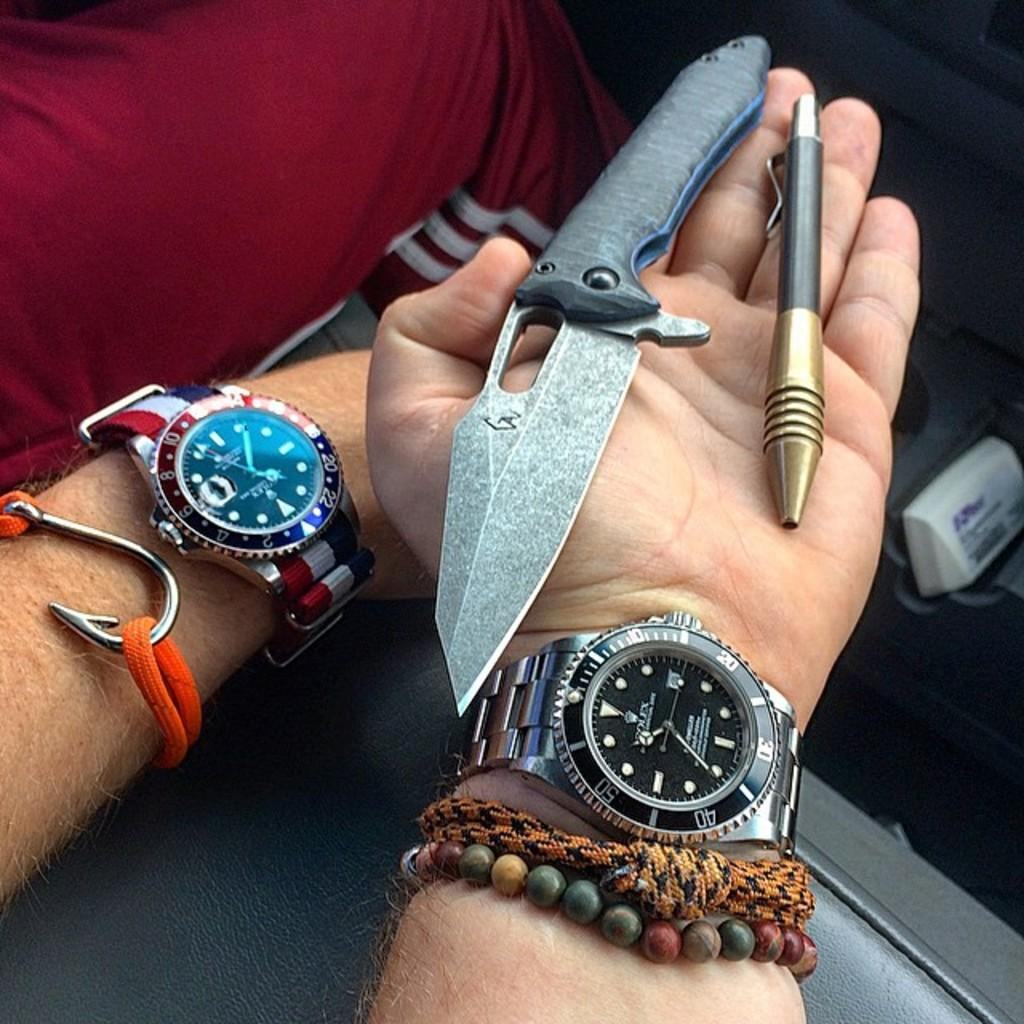<image>
Present a compact description of the photo's key features. Two arms wearing wristwatches are shown with the arm with a rolex holding a knife and a pen. 